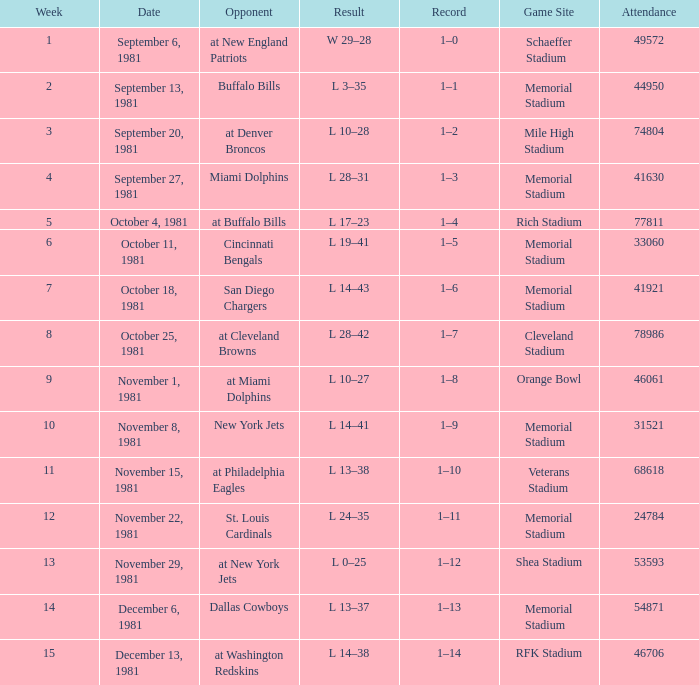When it is week 2 what is the record? 1–1. 